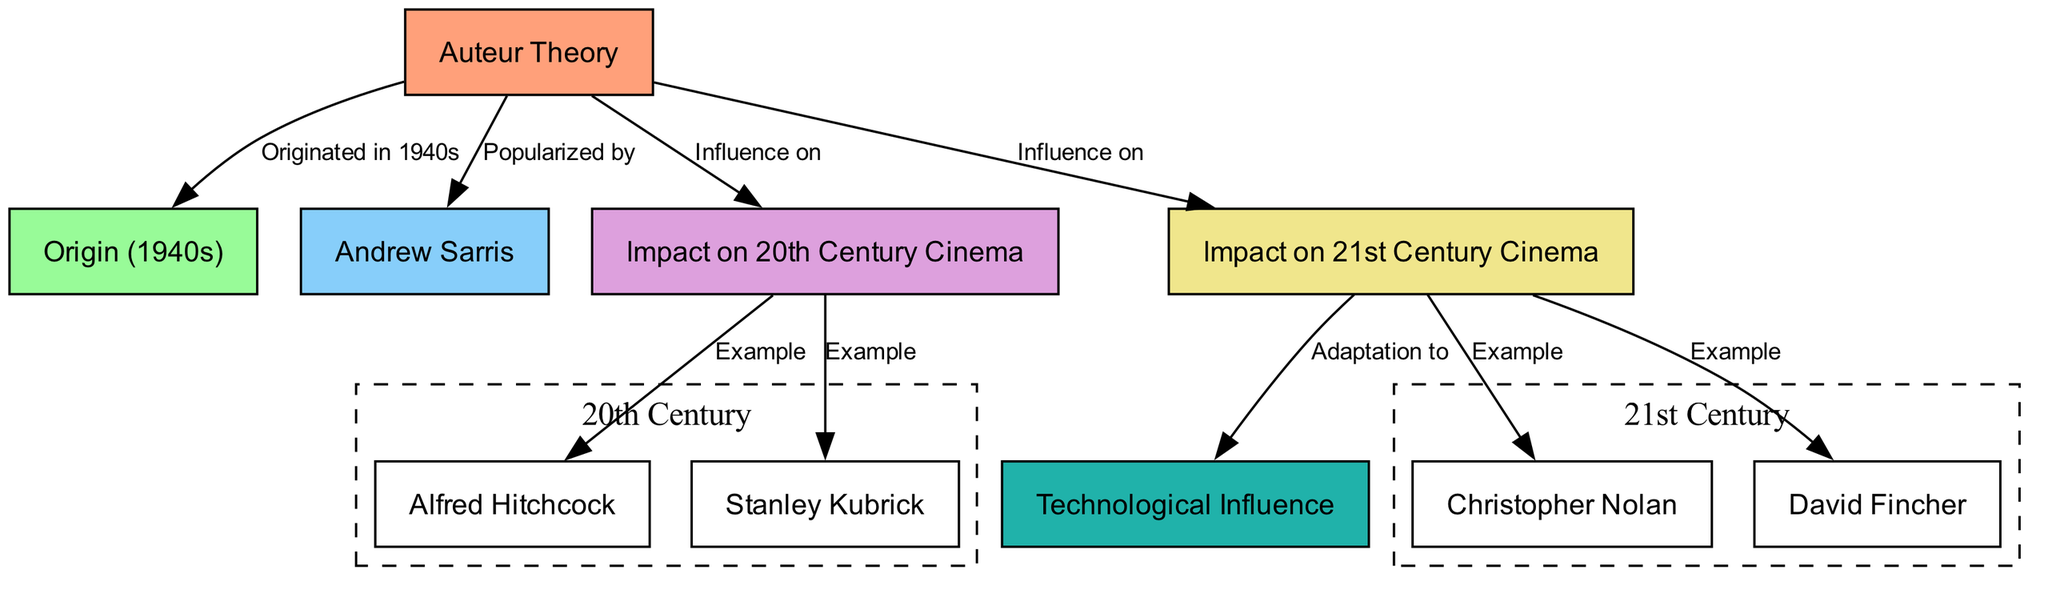What is the origin of auteur theory? The diagram specifies that auteur theory originated in the 1940s. This is directly indicated in the node labeled "Origin (1940s)" connected to the main node "Auteur Theory."
Answer: 1940s Who popularized auteur theory? The diagram shows that Andrew Sarris is the person who popularized auteur theory. This is indicated by the edge connecting the node "auteur_theory" to the node "Andrew Sarris."
Answer: Andrew Sarris How many filmmakers are listed as examples from the 20th Century? There are two examples listed; "Alfred Hitchcock" and "Stanley Kubrick." These are both located under the "Impact on 20th Century Cinema" node.
Answer: 2 What impact did auteur theory have on 21st Century cinema? The diagram indicates that auteur theory influenced 21st Century cinema and led to the emergence of various filmmakers. It is connected to the node "Impact on 21st Century Cinema."
Answer: Impact on 21st Century Cinema Which two filmmakers are highlighted as examples from the 21st Century? The diagram lists "Christopher Nolan" and "David Fincher" as examples of filmmakers influenced by auteur theory in the 21st Century. Both are under the node "Impact on 21st Century Cinema."
Answer: Christopher Nolan and David Fincher What does the "technological influence" node indicate? The node labeled "Technological Influence" indicates that the impact of auteur theory has adapted to technology. It is connected to the node "Impact on 21st Century Cinema," meaning that technology has played a role in how auteur theory is applied in modern films.
Answer: Adaptation to technology How does the influence of auteur theory connect between the 20th and 21st centuries? The influence of auteur theory flows from the "Impact on 20th Century Cinema" node to the "Impact on 21st Century Cinema" node, indicating a continuous influence from one century to the next.
Answer: Continuous influence What color represents the node for "Impact on 21st Century Cinema"? In the diagram's color scheme, the node for "Impact on 21st Century Cinema" is represented in a light yellow color, specifically noted as "#F0E68C."
Answer: Light yellow 